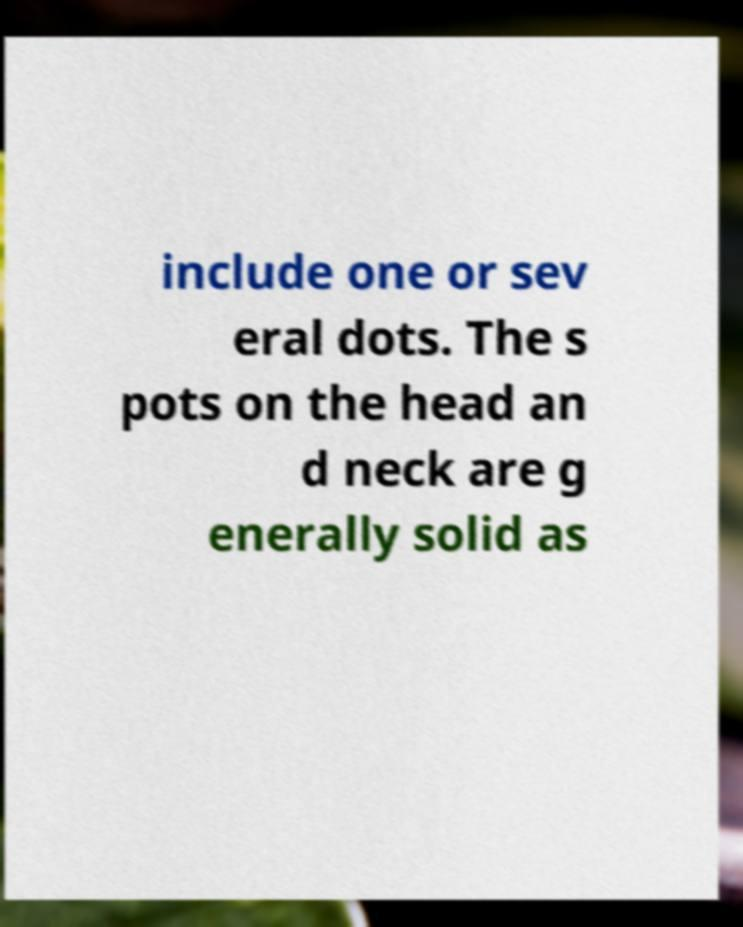For documentation purposes, I need the text within this image transcribed. Could you provide that? include one or sev eral dots. The s pots on the head an d neck are g enerally solid as 